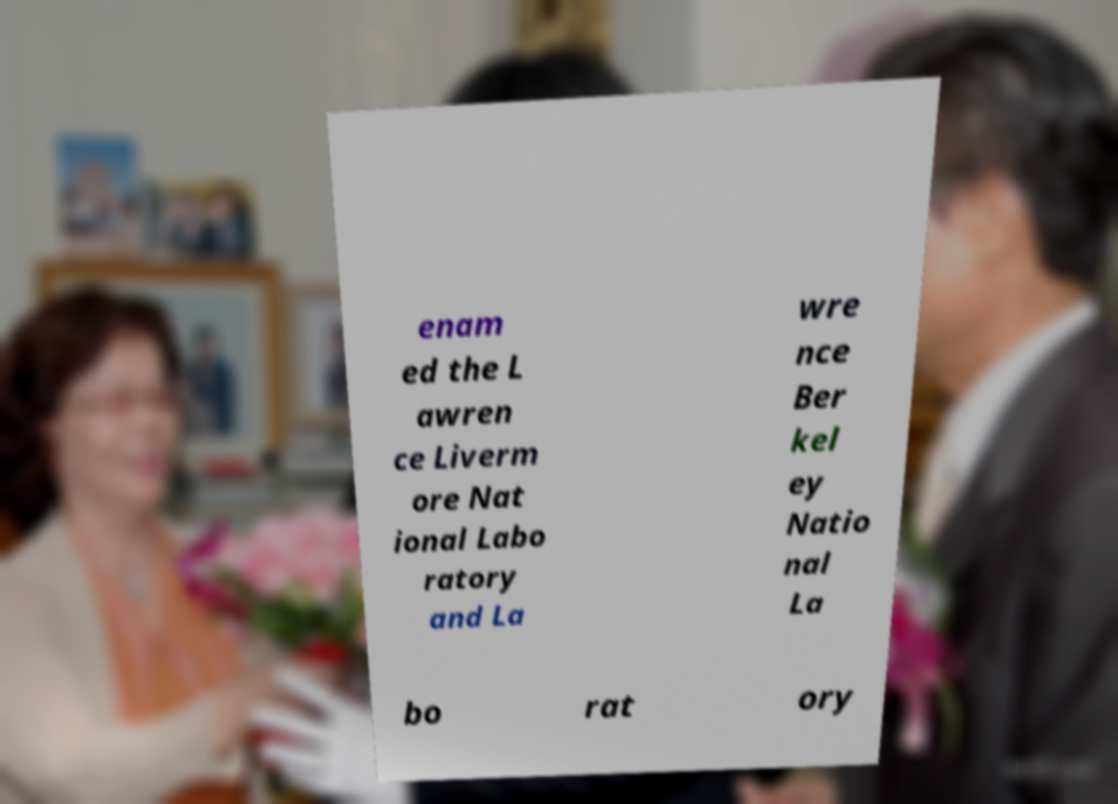For documentation purposes, I need the text within this image transcribed. Could you provide that? enam ed the L awren ce Liverm ore Nat ional Labo ratory and La wre nce Ber kel ey Natio nal La bo rat ory 